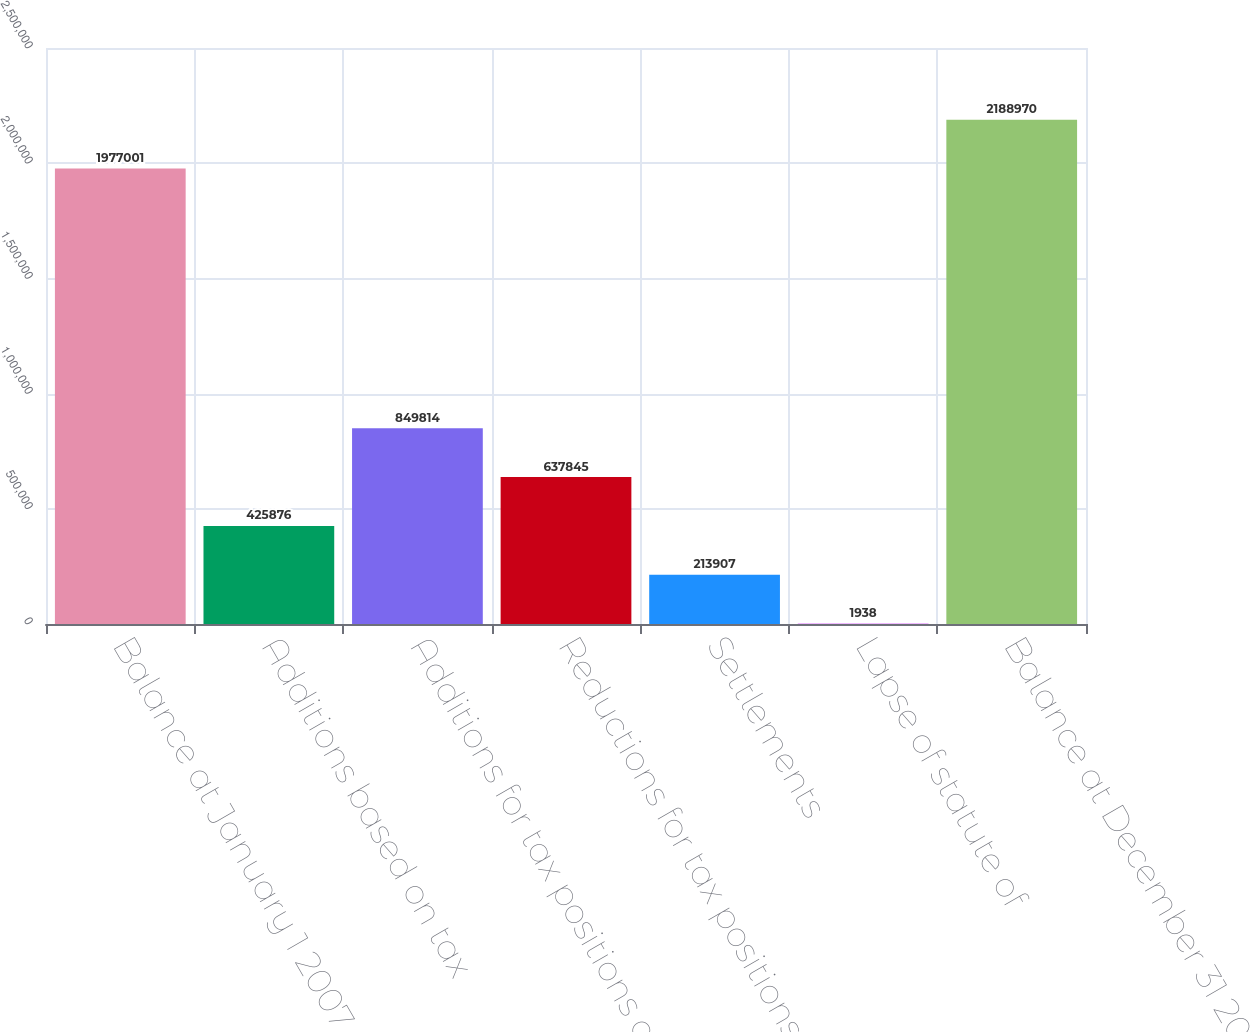Convert chart to OTSL. <chart><loc_0><loc_0><loc_500><loc_500><bar_chart><fcel>Balance at January 1 2007 upon<fcel>Additions based on tax<fcel>Additions for tax positions of<fcel>Reductions for tax positions<fcel>Settlements<fcel>Lapse of statute of<fcel>Balance at December 31 2007<nl><fcel>1.977e+06<fcel>425876<fcel>849814<fcel>637845<fcel>213907<fcel>1938<fcel>2.18897e+06<nl></chart> 